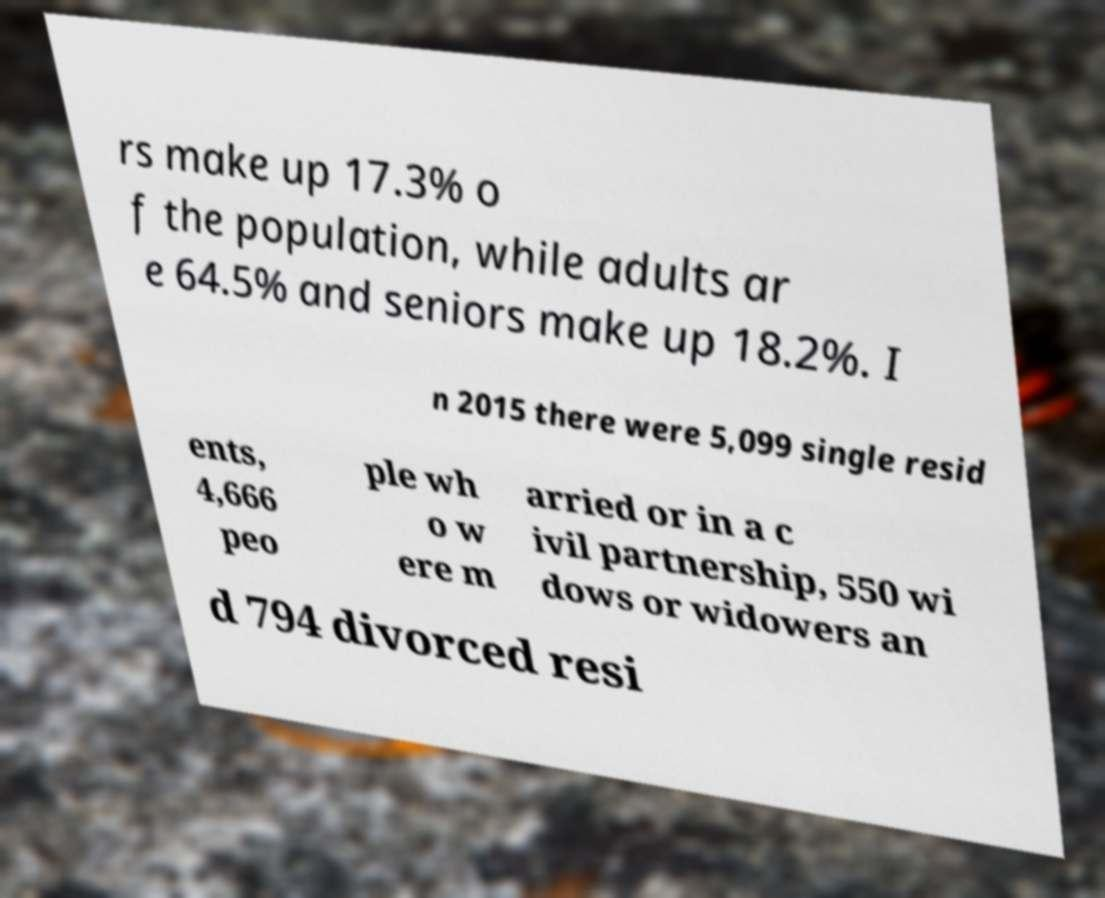What messages or text are displayed in this image? I need them in a readable, typed format. rs make up 17.3% o f the population, while adults ar e 64.5% and seniors make up 18.2%. I n 2015 there were 5,099 single resid ents, 4,666 peo ple wh o w ere m arried or in a c ivil partnership, 550 wi dows or widowers an d 794 divorced resi 